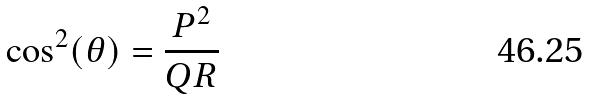Convert formula to latex. <formula><loc_0><loc_0><loc_500><loc_500>\cos ^ { 2 } ( \theta ) = \frac { P ^ { 2 } } { Q R }</formula> 